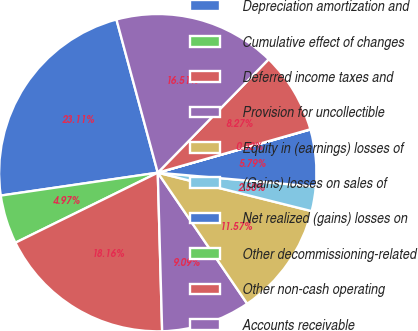Convert chart. <chart><loc_0><loc_0><loc_500><loc_500><pie_chart><fcel>Depreciation amortization and<fcel>Cumulative effect of changes<fcel>Deferred income taxes and<fcel>Provision for uncollectible<fcel>Equity in (earnings) losses of<fcel>(Gains) losses on sales of<fcel>Net realized (gains) losses on<fcel>Other decommissioning-related<fcel>Other non-cash operating<fcel>Accounts receivable<nl><fcel>23.11%<fcel>4.97%<fcel>18.16%<fcel>9.09%<fcel>11.57%<fcel>2.5%<fcel>5.79%<fcel>0.02%<fcel>8.27%<fcel>16.51%<nl></chart> 